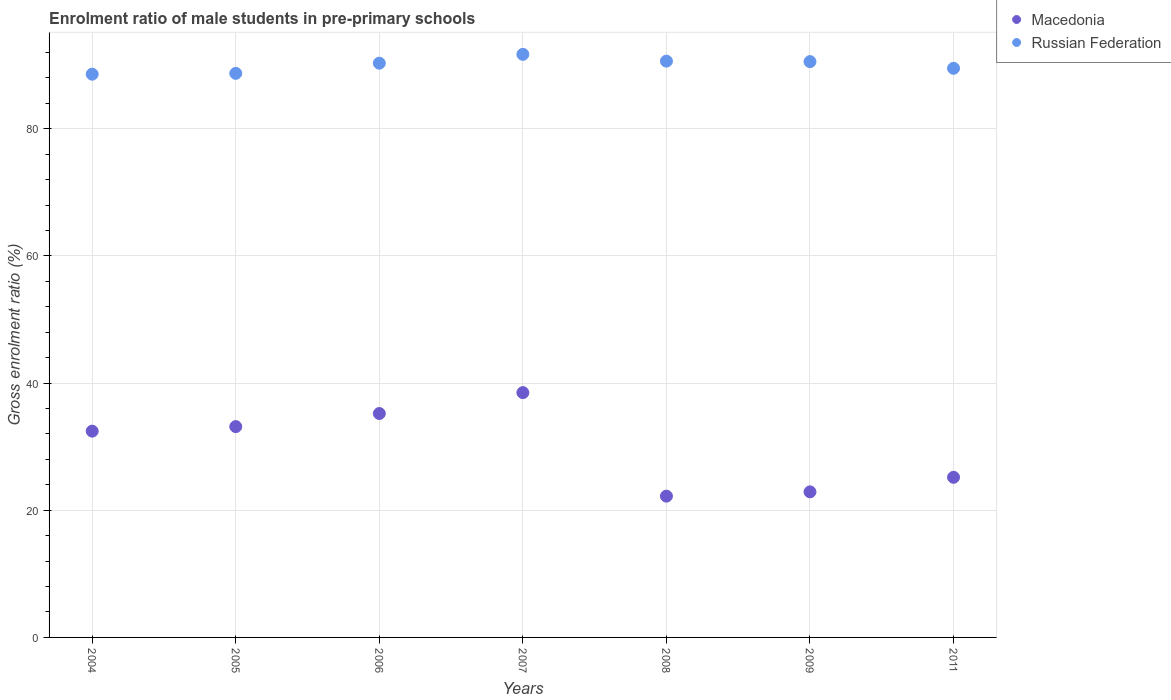Is the number of dotlines equal to the number of legend labels?
Make the answer very short. Yes. What is the enrolment ratio of male students in pre-primary schools in Russian Federation in 2007?
Ensure brevity in your answer.  91.72. Across all years, what is the maximum enrolment ratio of male students in pre-primary schools in Russian Federation?
Your answer should be very brief. 91.72. Across all years, what is the minimum enrolment ratio of male students in pre-primary schools in Russian Federation?
Keep it short and to the point. 88.6. What is the total enrolment ratio of male students in pre-primary schools in Russian Federation in the graph?
Offer a terse response. 630.12. What is the difference between the enrolment ratio of male students in pre-primary schools in Macedonia in 2005 and that in 2006?
Ensure brevity in your answer.  -2.06. What is the difference between the enrolment ratio of male students in pre-primary schools in Macedonia in 2004 and the enrolment ratio of male students in pre-primary schools in Russian Federation in 2009?
Provide a succinct answer. -58.13. What is the average enrolment ratio of male students in pre-primary schools in Russian Federation per year?
Keep it short and to the point. 90.02. In the year 2011, what is the difference between the enrolment ratio of male students in pre-primary schools in Russian Federation and enrolment ratio of male students in pre-primary schools in Macedonia?
Offer a very short reply. 64.34. What is the ratio of the enrolment ratio of male students in pre-primary schools in Macedonia in 2007 to that in 2011?
Your answer should be very brief. 1.53. Is the enrolment ratio of male students in pre-primary schools in Macedonia in 2006 less than that in 2009?
Give a very brief answer. No. Is the difference between the enrolment ratio of male students in pre-primary schools in Russian Federation in 2009 and 2011 greater than the difference between the enrolment ratio of male students in pre-primary schools in Macedonia in 2009 and 2011?
Provide a succinct answer. Yes. What is the difference between the highest and the second highest enrolment ratio of male students in pre-primary schools in Macedonia?
Your response must be concise. 3.28. What is the difference between the highest and the lowest enrolment ratio of male students in pre-primary schools in Russian Federation?
Provide a succinct answer. 3.12. Is the sum of the enrolment ratio of male students in pre-primary schools in Macedonia in 2008 and 2011 greater than the maximum enrolment ratio of male students in pre-primary schools in Russian Federation across all years?
Make the answer very short. No. Is the enrolment ratio of male students in pre-primary schools in Russian Federation strictly greater than the enrolment ratio of male students in pre-primary schools in Macedonia over the years?
Make the answer very short. Yes. Is the enrolment ratio of male students in pre-primary schools in Macedonia strictly less than the enrolment ratio of male students in pre-primary schools in Russian Federation over the years?
Ensure brevity in your answer.  Yes. Where does the legend appear in the graph?
Your answer should be compact. Top right. What is the title of the graph?
Your answer should be compact. Enrolment ratio of male students in pre-primary schools. Does "Netherlands" appear as one of the legend labels in the graph?
Offer a very short reply. No. What is the label or title of the Y-axis?
Your answer should be compact. Gross enrolment ratio (%). What is the Gross enrolment ratio (%) in Macedonia in 2004?
Make the answer very short. 32.45. What is the Gross enrolment ratio (%) of Russian Federation in 2004?
Provide a succinct answer. 88.6. What is the Gross enrolment ratio (%) in Macedonia in 2005?
Provide a short and direct response. 33.16. What is the Gross enrolment ratio (%) of Russian Federation in 2005?
Offer a very short reply. 88.73. What is the Gross enrolment ratio (%) of Macedonia in 2006?
Keep it short and to the point. 35.22. What is the Gross enrolment ratio (%) in Russian Federation in 2006?
Your answer should be very brief. 90.33. What is the Gross enrolment ratio (%) in Macedonia in 2007?
Ensure brevity in your answer.  38.51. What is the Gross enrolment ratio (%) in Russian Federation in 2007?
Provide a short and direct response. 91.72. What is the Gross enrolment ratio (%) of Macedonia in 2008?
Give a very brief answer. 22.22. What is the Gross enrolment ratio (%) of Russian Federation in 2008?
Make the answer very short. 90.65. What is the Gross enrolment ratio (%) in Macedonia in 2009?
Offer a very short reply. 22.9. What is the Gross enrolment ratio (%) of Russian Federation in 2009?
Ensure brevity in your answer.  90.57. What is the Gross enrolment ratio (%) of Macedonia in 2011?
Keep it short and to the point. 25.19. What is the Gross enrolment ratio (%) in Russian Federation in 2011?
Provide a short and direct response. 89.52. Across all years, what is the maximum Gross enrolment ratio (%) of Macedonia?
Your answer should be very brief. 38.51. Across all years, what is the maximum Gross enrolment ratio (%) of Russian Federation?
Ensure brevity in your answer.  91.72. Across all years, what is the minimum Gross enrolment ratio (%) of Macedonia?
Make the answer very short. 22.22. Across all years, what is the minimum Gross enrolment ratio (%) in Russian Federation?
Make the answer very short. 88.6. What is the total Gross enrolment ratio (%) in Macedonia in the graph?
Give a very brief answer. 209.64. What is the total Gross enrolment ratio (%) of Russian Federation in the graph?
Provide a short and direct response. 630.12. What is the difference between the Gross enrolment ratio (%) of Macedonia in 2004 and that in 2005?
Give a very brief answer. -0.71. What is the difference between the Gross enrolment ratio (%) in Russian Federation in 2004 and that in 2005?
Your answer should be compact. -0.13. What is the difference between the Gross enrolment ratio (%) in Macedonia in 2004 and that in 2006?
Your response must be concise. -2.77. What is the difference between the Gross enrolment ratio (%) of Russian Federation in 2004 and that in 2006?
Ensure brevity in your answer.  -1.73. What is the difference between the Gross enrolment ratio (%) in Macedonia in 2004 and that in 2007?
Your answer should be very brief. -6.06. What is the difference between the Gross enrolment ratio (%) of Russian Federation in 2004 and that in 2007?
Your answer should be compact. -3.12. What is the difference between the Gross enrolment ratio (%) of Macedonia in 2004 and that in 2008?
Give a very brief answer. 10.22. What is the difference between the Gross enrolment ratio (%) in Russian Federation in 2004 and that in 2008?
Provide a short and direct response. -2.05. What is the difference between the Gross enrolment ratio (%) in Macedonia in 2004 and that in 2009?
Your response must be concise. 9.55. What is the difference between the Gross enrolment ratio (%) in Russian Federation in 2004 and that in 2009?
Ensure brevity in your answer.  -1.97. What is the difference between the Gross enrolment ratio (%) of Macedonia in 2004 and that in 2011?
Ensure brevity in your answer.  7.26. What is the difference between the Gross enrolment ratio (%) of Russian Federation in 2004 and that in 2011?
Give a very brief answer. -0.93. What is the difference between the Gross enrolment ratio (%) of Macedonia in 2005 and that in 2006?
Keep it short and to the point. -2.06. What is the difference between the Gross enrolment ratio (%) of Russian Federation in 2005 and that in 2006?
Give a very brief answer. -1.6. What is the difference between the Gross enrolment ratio (%) in Macedonia in 2005 and that in 2007?
Provide a succinct answer. -5.35. What is the difference between the Gross enrolment ratio (%) of Russian Federation in 2005 and that in 2007?
Your answer should be compact. -2.99. What is the difference between the Gross enrolment ratio (%) in Macedonia in 2005 and that in 2008?
Offer a terse response. 10.94. What is the difference between the Gross enrolment ratio (%) in Russian Federation in 2005 and that in 2008?
Offer a terse response. -1.92. What is the difference between the Gross enrolment ratio (%) in Macedonia in 2005 and that in 2009?
Make the answer very short. 10.26. What is the difference between the Gross enrolment ratio (%) in Russian Federation in 2005 and that in 2009?
Provide a short and direct response. -1.84. What is the difference between the Gross enrolment ratio (%) of Macedonia in 2005 and that in 2011?
Give a very brief answer. 7.97. What is the difference between the Gross enrolment ratio (%) in Russian Federation in 2005 and that in 2011?
Give a very brief answer. -0.79. What is the difference between the Gross enrolment ratio (%) of Macedonia in 2006 and that in 2007?
Provide a succinct answer. -3.28. What is the difference between the Gross enrolment ratio (%) of Russian Federation in 2006 and that in 2007?
Provide a short and direct response. -1.39. What is the difference between the Gross enrolment ratio (%) in Macedonia in 2006 and that in 2008?
Your response must be concise. 13. What is the difference between the Gross enrolment ratio (%) of Russian Federation in 2006 and that in 2008?
Provide a short and direct response. -0.32. What is the difference between the Gross enrolment ratio (%) in Macedonia in 2006 and that in 2009?
Make the answer very short. 12.32. What is the difference between the Gross enrolment ratio (%) in Russian Federation in 2006 and that in 2009?
Offer a very short reply. -0.25. What is the difference between the Gross enrolment ratio (%) in Macedonia in 2006 and that in 2011?
Your answer should be very brief. 10.03. What is the difference between the Gross enrolment ratio (%) in Russian Federation in 2006 and that in 2011?
Your response must be concise. 0.8. What is the difference between the Gross enrolment ratio (%) in Macedonia in 2007 and that in 2008?
Ensure brevity in your answer.  16.28. What is the difference between the Gross enrolment ratio (%) in Russian Federation in 2007 and that in 2008?
Offer a terse response. 1.07. What is the difference between the Gross enrolment ratio (%) of Macedonia in 2007 and that in 2009?
Offer a terse response. 15.61. What is the difference between the Gross enrolment ratio (%) in Russian Federation in 2007 and that in 2009?
Provide a short and direct response. 1.15. What is the difference between the Gross enrolment ratio (%) in Macedonia in 2007 and that in 2011?
Keep it short and to the point. 13.32. What is the difference between the Gross enrolment ratio (%) of Russian Federation in 2007 and that in 2011?
Your answer should be very brief. 2.2. What is the difference between the Gross enrolment ratio (%) of Macedonia in 2008 and that in 2009?
Offer a terse response. -0.67. What is the difference between the Gross enrolment ratio (%) in Russian Federation in 2008 and that in 2009?
Your response must be concise. 0.08. What is the difference between the Gross enrolment ratio (%) of Macedonia in 2008 and that in 2011?
Provide a short and direct response. -2.96. What is the difference between the Gross enrolment ratio (%) of Russian Federation in 2008 and that in 2011?
Provide a short and direct response. 1.13. What is the difference between the Gross enrolment ratio (%) in Macedonia in 2009 and that in 2011?
Your answer should be very brief. -2.29. What is the difference between the Gross enrolment ratio (%) in Russian Federation in 2009 and that in 2011?
Your answer should be compact. 1.05. What is the difference between the Gross enrolment ratio (%) in Macedonia in 2004 and the Gross enrolment ratio (%) in Russian Federation in 2005?
Keep it short and to the point. -56.28. What is the difference between the Gross enrolment ratio (%) of Macedonia in 2004 and the Gross enrolment ratio (%) of Russian Federation in 2006?
Your response must be concise. -57.88. What is the difference between the Gross enrolment ratio (%) of Macedonia in 2004 and the Gross enrolment ratio (%) of Russian Federation in 2007?
Ensure brevity in your answer.  -59.27. What is the difference between the Gross enrolment ratio (%) of Macedonia in 2004 and the Gross enrolment ratio (%) of Russian Federation in 2008?
Your response must be concise. -58.2. What is the difference between the Gross enrolment ratio (%) in Macedonia in 2004 and the Gross enrolment ratio (%) in Russian Federation in 2009?
Keep it short and to the point. -58.13. What is the difference between the Gross enrolment ratio (%) in Macedonia in 2004 and the Gross enrolment ratio (%) in Russian Federation in 2011?
Make the answer very short. -57.08. What is the difference between the Gross enrolment ratio (%) in Macedonia in 2005 and the Gross enrolment ratio (%) in Russian Federation in 2006?
Offer a terse response. -57.17. What is the difference between the Gross enrolment ratio (%) in Macedonia in 2005 and the Gross enrolment ratio (%) in Russian Federation in 2007?
Your answer should be very brief. -58.56. What is the difference between the Gross enrolment ratio (%) of Macedonia in 2005 and the Gross enrolment ratio (%) of Russian Federation in 2008?
Offer a very short reply. -57.49. What is the difference between the Gross enrolment ratio (%) of Macedonia in 2005 and the Gross enrolment ratio (%) of Russian Federation in 2009?
Your answer should be compact. -57.41. What is the difference between the Gross enrolment ratio (%) of Macedonia in 2005 and the Gross enrolment ratio (%) of Russian Federation in 2011?
Your response must be concise. -56.36. What is the difference between the Gross enrolment ratio (%) of Macedonia in 2006 and the Gross enrolment ratio (%) of Russian Federation in 2007?
Give a very brief answer. -56.5. What is the difference between the Gross enrolment ratio (%) in Macedonia in 2006 and the Gross enrolment ratio (%) in Russian Federation in 2008?
Your response must be concise. -55.43. What is the difference between the Gross enrolment ratio (%) in Macedonia in 2006 and the Gross enrolment ratio (%) in Russian Federation in 2009?
Offer a terse response. -55.35. What is the difference between the Gross enrolment ratio (%) of Macedonia in 2006 and the Gross enrolment ratio (%) of Russian Federation in 2011?
Your answer should be compact. -54.3. What is the difference between the Gross enrolment ratio (%) in Macedonia in 2007 and the Gross enrolment ratio (%) in Russian Federation in 2008?
Your answer should be very brief. -52.14. What is the difference between the Gross enrolment ratio (%) in Macedonia in 2007 and the Gross enrolment ratio (%) in Russian Federation in 2009?
Offer a terse response. -52.07. What is the difference between the Gross enrolment ratio (%) of Macedonia in 2007 and the Gross enrolment ratio (%) of Russian Federation in 2011?
Offer a terse response. -51.02. What is the difference between the Gross enrolment ratio (%) in Macedonia in 2008 and the Gross enrolment ratio (%) in Russian Federation in 2009?
Ensure brevity in your answer.  -68.35. What is the difference between the Gross enrolment ratio (%) of Macedonia in 2008 and the Gross enrolment ratio (%) of Russian Federation in 2011?
Offer a terse response. -67.3. What is the difference between the Gross enrolment ratio (%) in Macedonia in 2009 and the Gross enrolment ratio (%) in Russian Federation in 2011?
Offer a terse response. -66.62. What is the average Gross enrolment ratio (%) in Macedonia per year?
Keep it short and to the point. 29.95. What is the average Gross enrolment ratio (%) in Russian Federation per year?
Make the answer very short. 90.02. In the year 2004, what is the difference between the Gross enrolment ratio (%) of Macedonia and Gross enrolment ratio (%) of Russian Federation?
Your response must be concise. -56.15. In the year 2005, what is the difference between the Gross enrolment ratio (%) in Macedonia and Gross enrolment ratio (%) in Russian Federation?
Keep it short and to the point. -55.57. In the year 2006, what is the difference between the Gross enrolment ratio (%) in Macedonia and Gross enrolment ratio (%) in Russian Federation?
Offer a very short reply. -55.1. In the year 2007, what is the difference between the Gross enrolment ratio (%) in Macedonia and Gross enrolment ratio (%) in Russian Federation?
Provide a succinct answer. -53.21. In the year 2008, what is the difference between the Gross enrolment ratio (%) of Macedonia and Gross enrolment ratio (%) of Russian Federation?
Provide a succinct answer. -68.43. In the year 2009, what is the difference between the Gross enrolment ratio (%) of Macedonia and Gross enrolment ratio (%) of Russian Federation?
Offer a very short reply. -67.67. In the year 2011, what is the difference between the Gross enrolment ratio (%) of Macedonia and Gross enrolment ratio (%) of Russian Federation?
Offer a terse response. -64.34. What is the ratio of the Gross enrolment ratio (%) of Macedonia in 2004 to that in 2005?
Make the answer very short. 0.98. What is the ratio of the Gross enrolment ratio (%) of Macedonia in 2004 to that in 2006?
Give a very brief answer. 0.92. What is the ratio of the Gross enrolment ratio (%) of Russian Federation in 2004 to that in 2006?
Ensure brevity in your answer.  0.98. What is the ratio of the Gross enrolment ratio (%) of Macedonia in 2004 to that in 2007?
Your answer should be compact. 0.84. What is the ratio of the Gross enrolment ratio (%) in Russian Federation in 2004 to that in 2007?
Provide a short and direct response. 0.97. What is the ratio of the Gross enrolment ratio (%) of Macedonia in 2004 to that in 2008?
Ensure brevity in your answer.  1.46. What is the ratio of the Gross enrolment ratio (%) in Russian Federation in 2004 to that in 2008?
Ensure brevity in your answer.  0.98. What is the ratio of the Gross enrolment ratio (%) in Macedonia in 2004 to that in 2009?
Offer a very short reply. 1.42. What is the ratio of the Gross enrolment ratio (%) in Russian Federation in 2004 to that in 2009?
Keep it short and to the point. 0.98. What is the ratio of the Gross enrolment ratio (%) in Macedonia in 2004 to that in 2011?
Keep it short and to the point. 1.29. What is the ratio of the Gross enrolment ratio (%) of Macedonia in 2005 to that in 2006?
Your answer should be compact. 0.94. What is the ratio of the Gross enrolment ratio (%) of Russian Federation in 2005 to that in 2006?
Give a very brief answer. 0.98. What is the ratio of the Gross enrolment ratio (%) in Macedonia in 2005 to that in 2007?
Your response must be concise. 0.86. What is the ratio of the Gross enrolment ratio (%) in Russian Federation in 2005 to that in 2007?
Provide a short and direct response. 0.97. What is the ratio of the Gross enrolment ratio (%) in Macedonia in 2005 to that in 2008?
Provide a succinct answer. 1.49. What is the ratio of the Gross enrolment ratio (%) in Russian Federation in 2005 to that in 2008?
Give a very brief answer. 0.98. What is the ratio of the Gross enrolment ratio (%) in Macedonia in 2005 to that in 2009?
Your response must be concise. 1.45. What is the ratio of the Gross enrolment ratio (%) of Russian Federation in 2005 to that in 2009?
Keep it short and to the point. 0.98. What is the ratio of the Gross enrolment ratio (%) of Macedonia in 2005 to that in 2011?
Ensure brevity in your answer.  1.32. What is the ratio of the Gross enrolment ratio (%) of Russian Federation in 2005 to that in 2011?
Provide a succinct answer. 0.99. What is the ratio of the Gross enrolment ratio (%) of Macedonia in 2006 to that in 2007?
Offer a terse response. 0.91. What is the ratio of the Gross enrolment ratio (%) of Russian Federation in 2006 to that in 2007?
Offer a very short reply. 0.98. What is the ratio of the Gross enrolment ratio (%) in Macedonia in 2006 to that in 2008?
Give a very brief answer. 1.58. What is the ratio of the Gross enrolment ratio (%) in Macedonia in 2006 to that in 2009?
Your answer should be very brief. 1.54. What is the ratio of the Gross enrolment ratio (%) of Russian Federation in 2006 to that in 2009?
Your answer should be compact. 1. What is the ratio of the Gross enrolment ratio (%) of Macedonia in 2006 to that in 2011?
Give a very brief answer. 1.4. What is the ratio of the Gross enrolment ratio (%) in Macedonia in 2007 to that in 2008?
Provide a short and direct response. 1.73. What is the ratio of the Gross enrolment ratio (%) in Russian Federation in 2007 to that in 2008?
Your answer should be very brief. 1.01. What is the ratio of the Gross enrolment ratio (%) in Macedonia in 2007 to that in 2009?
Give a very brief answer. 1.68. What is the ratio of the Gross enrolment ratio (%) in Russian Federation in 2007 to that in 2009?
Your response must be concise. 1.01. What is the ratio of the Gross enrolment ratio (%) in Macedonia in 2007 to that in 2011?
Make the answer very short. 1.53. What is the ratio of the Gross enrolment ratio (%) of Russian Federation in 2007 to that in 2011?
Your response must be concise. 1.02. What is the ratio of the Gross enrolment ratio (%) of Macedonia in 2008 to that in 2009?
Your answer should be compact. 0.97. What is the ratio of the Gross enrolment ratio (%) in Macedonia in 2008 to that in 2011?
Make the answer very short. 0.88. What is the ratio of the Gross enrolment ratio (%) of Russian Federation in 2008 to that in 2011?
Provide a short and direct response. 1.01. What is the ratio of the Gross enrolment ratio (%) of Macedonia in 2009 to that in 2011?
Offer a very short reply. 0.91. What is the ratio of the Gross enrolment ratio (%) in Russian Federation in 2009 to that in 2011?
Keep it short and to the point. 1.01. What is the difference between the highest and the second highest Gross enrolment ratio (%) of Macedonia?
Offer a terse response. 3.28. What is the difference between the highest and the second highest Gross enrolment ratio (%) of Russian Federation?
Keep it short and to the point. 1.07. What is the difference between the highest and the lowest Gross enrolment ratio (%) in Macedonia?
Keep it short and to the point. 16.28. What is the difference between the highest and the lowest Gross enrolment ratio (%) in Russian Federation?
Make the answer very short. 3.12. 